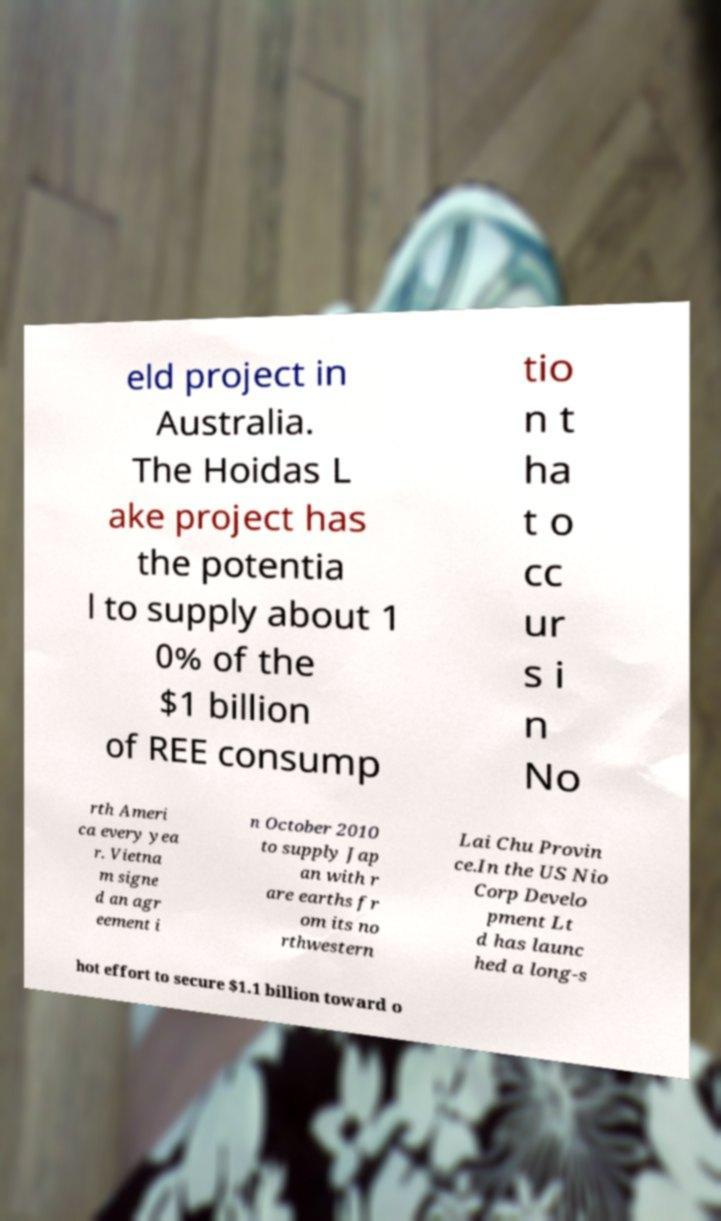Could you assist in decoding the text presented in this image and type it out clearly? eld project in Australia. The Hoidas L ake project has the potentia l to supply about 1 0% of the $1 billion of REE consump tio n t ha t o cc ur s i n No rth Ameri ca every yea r. Vietna m signe d an agr eement i n October 2010 to supply Jap an with r are earths fr om its no rthwestern Lai Chu Provin ce.In the US Nio Corp Develo pment Lt d has launc hed a long-s hot effort to secure $1.1 billion toward o 